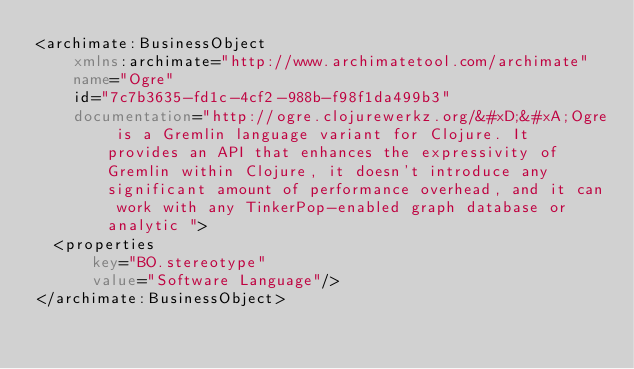Convert code to text. <code><loc_0><loc_0><loc_500><loc_500><_XML_><archimate:BusinessObject
    xmlns:archimate="http://www.archimatetool.com/archimate"
    name="Ogre"
    id="7c7b3635-fd1c-4cf2-988b-f98f1da499b3"
    documentation="http://ogre.clojurewerkz.org/&#xD;&#xA;Ogre is a Gremlin language variant for Clojure. It provides an API that enhances the expressivity of Gremlin within Clojure, it doesn't introduce any significant amount of performance overhead, and it can work with any TinkerPop-enabled graph database or analytic ">
  <properties
      key="BO.stereotype"
      value="Software Language"/>
</archimate:BusinessObject>
</code> 